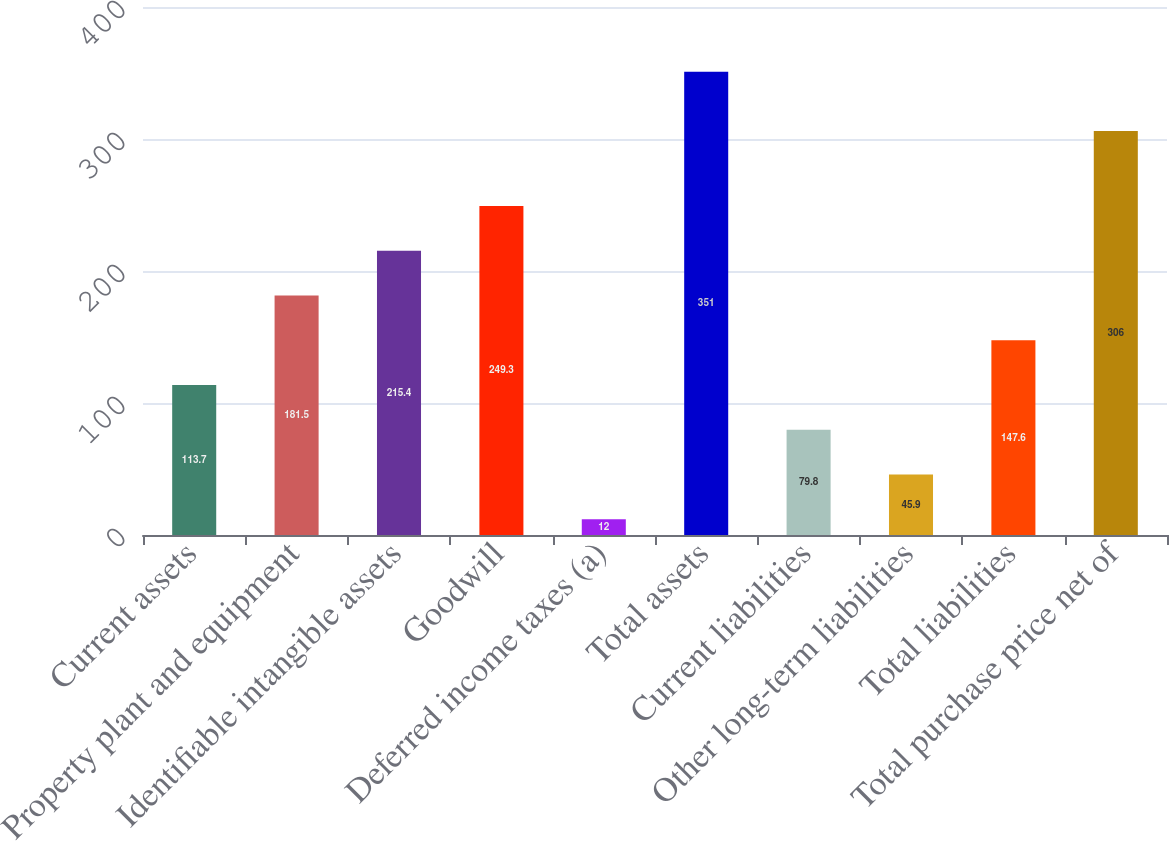Convert chart to OTSL. <chart><loc_0><loc_0><loc_500><loc_500><bar_chart><fcel>Current assets<fcel>Property plant and equipment<fcel>Identifiable intangible assets<fcel>Goodwill<fcel>Deferred income taxes (a)<fcel>Total assets<fcel>Current liabilities<fcel>Other long-term liabilities<fcel>Total liabilities<fcel>Total purchase price net of<nl><fcel>113.7<fcel>181.5<fcel>215.4<fcel>249.3<fcel>12<fcel>351<fcel>79.8<fcel>45.9<fcel>147.6<fcel>306<nl></chart> 